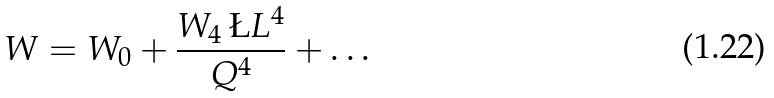Convert formula to latex. <formula><loc_0><loc_0><loc_500><loc_500>W = W _ { 0 } + \frac { W _ { 4 } \, \L L ^ { 4 } } { Q ^ { 4 } } + \dots</formula> 